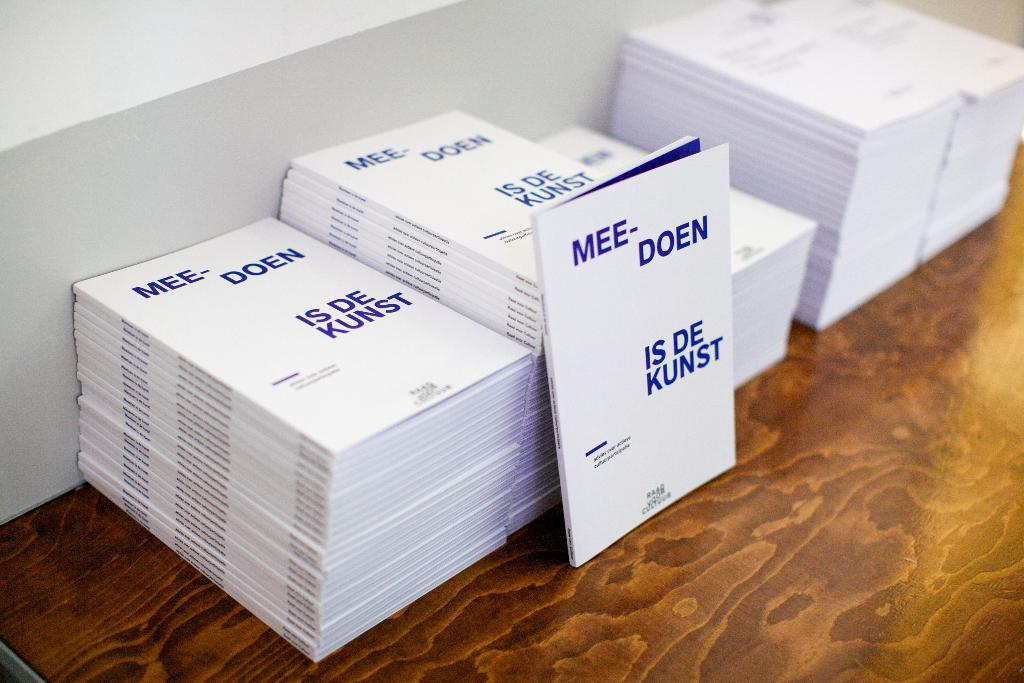<image>
Summarize the visual content of the image. Stacks of booklets on a table read "Mee-Doen, Is De Kunst". 